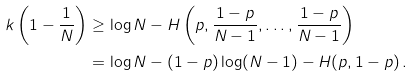Convert formula to latex. <formula><loc_0><loc_0><loc_500><loc_500>k \left ( { 1 - \frac { 1 } { N } } \right ) & \geq \log N - H \left ( { p , \frac { 1 - p } { N - 1 } , \dots , \frac { 1 - p } { N - 1 } } \right ) \\ & = \log N - ( 1 - p ) \log ( N - 1 ) - H ( p , 1 - p ) \, .</formula> 